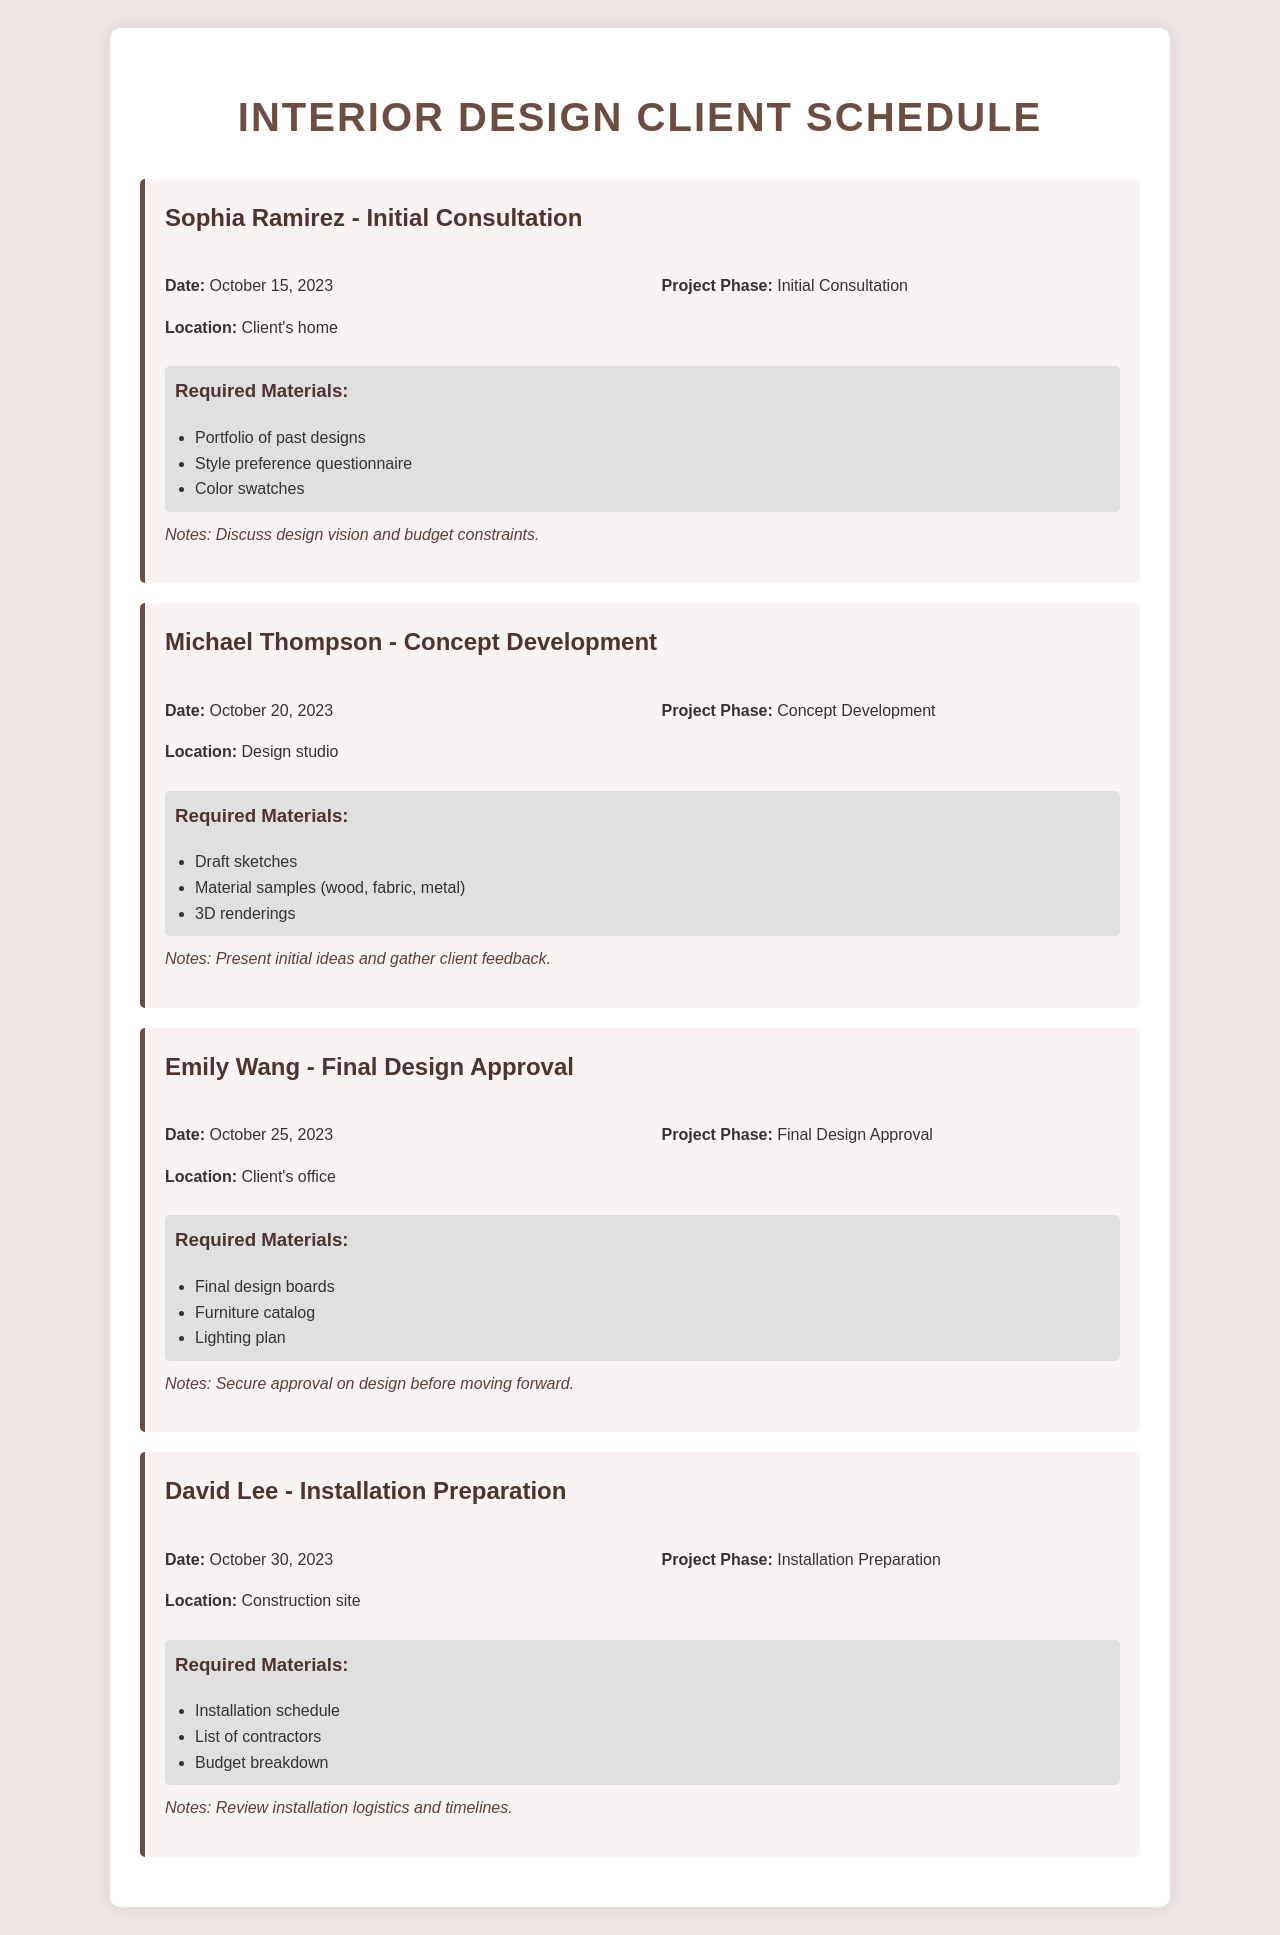What is the date of the initial consultation with Sophia Ramirez? The document states that the initial consultation with Sophia Ramirez is scheduled for October 15, 2023.
Answer: October 15, 2023 Where will the concept development meeting with Michael Thompson take place? According to the document, the concept development meeting with Michael Thompson will take place at the design studio.
Answer: Design studio What is the project phase for Emily Wang's meeting? The document lists the project phase for Emily Wang's meeting as final design approval.
Answer: Final Design Approval Which materials are required for the installation preparation meeting with David Lee? The document details the required materials for the installation preparation meeting as installation schedule, list of contractors, and budget breakdown.
Answer: Installation schedule, list of contractors, budget breakdown How many days are there between the initial consultation and the concept development meeting? The document states the dates of the meetings, with the initial consultation on October 15 and the concept development meeting on October 20, making it a difference of 5 days.
Answer: 5 days What is noted in the notes for the final design approval meeting? The notes section for Emily Wang's meeting indicates that the goal is to secure approval on the design before moving forward.
Answer: Secure approval on design Who is the client for the installation preparation meeting? The document identifies David Lee as the client for the installation preparation meeting.
Answer: David Lee What is the main purpose of the initial consultation meeting? The document mentions that the purpose of the initial consultation with Sophia Ramirez is to discuss design vision and budget constraints.
Answer: Discuss design vision and budget constraints How many client meetings are scheduled in total? The document lists four client meetings scheduled, each with different clients and phases.
Answer: Four meetings 